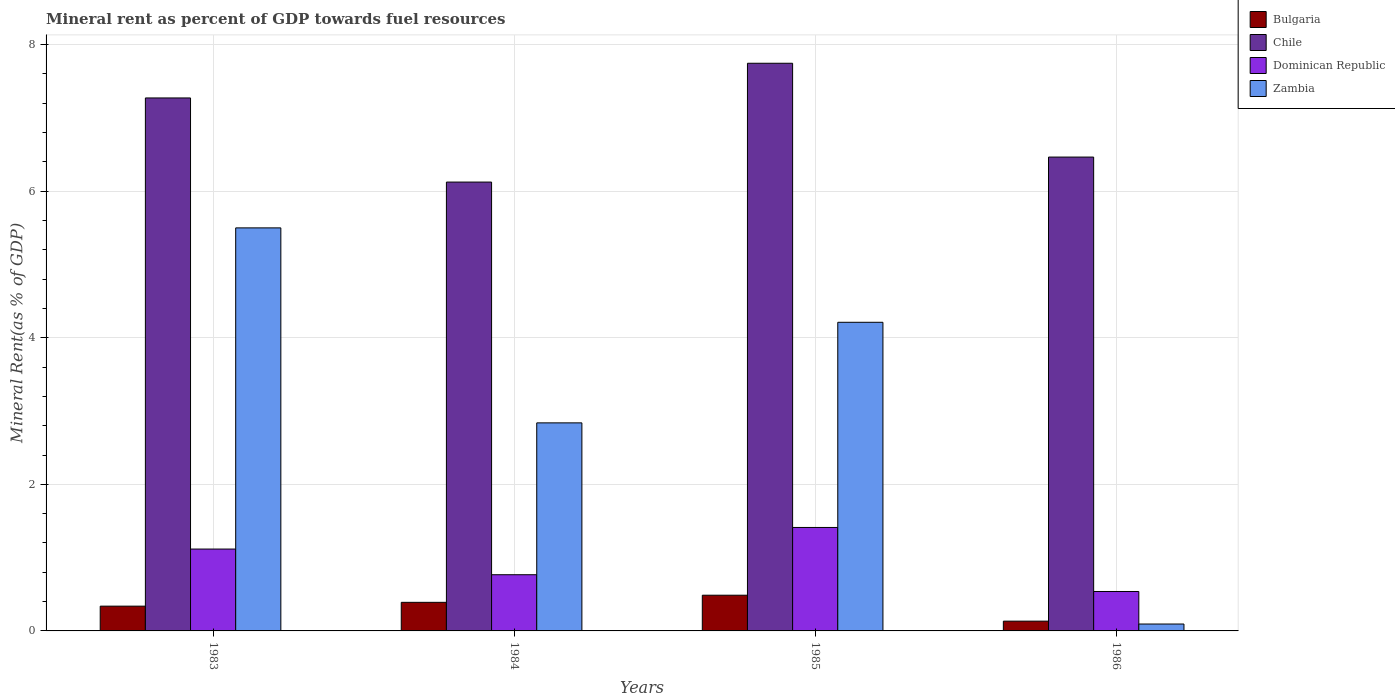Are the number of bars per tick equal to the number of legend labels?
Your answer should be compact. Yes. Are the number of bars on each tick of the X-axis equal?
Your response must be concise. Yes. How many bars are there on the 4th tick from the left?
Offer a very short reply. 4. How many bars are there on the 4th tick from the right?
Offer a terse response. 4. What is the mineral rent in Chile in 1986?
Your answer should be very brief. 6.47. Across all years, what is the maximum mineral rent in Dominican Republic?
Offer a terse response. 1.41. Across all years, what is the minimum mineral rent in Zambia?
Offer a terse response. 0.09. In which year was the mineral rent in Dominican Republic minimum?
Make the answer very short. 1986. What is the total mineral rent in Dominican Republic in the graph?
Keep it short and to the point. 3.83. What is the difference between the mineral rent in Zambia in 1983 and that in 1985?
Give a very brief answer. 1.29. What is the difference between the mineral rent in Dominican Republic in 1983 and the mineral rent in Bulgaria in 1984?
Offer a terse response. 0.73. What is the average mineral rent in Chile per year?
Give a very brief answer. 6.9. In the year 1983, what is the difference between the mineral rent in Bulgaria and mineral rent in Dominican Republic?
Ensure brevity in your answer.  -0.78. In how many years, is the mineral rent in Zambia greater than 2.4 %?
Keep it short and to the point. 3. What is the ratio of the mineral rent in Chile in 1983 to that in 1985?
Your response must be concise. 0.94. Is the difference between the mineral rent in Bulgaria in 1983 and 1984 greater than the difference between the mineral rent in Dominican Republic in 1983 and 1984?
Offer a terse response. No. What is the difference between the highest and the second highest mineral rent in Bulgaria?
Ensure brevity in your answer.  0.1. What is the difference between the highest and the lowest mineral rent in Dominican Republic?
Your answer should be very brief. 0.87. Is the sum of the mineral rent in Zambia in 1983 and 1985 greater than the maximum mineral rent in Dominican Republic across all years?
Give a very brief answer. Yes. Is it the case that in every year, the sum of the mineral rent in Chile and mineral rent in Bulgaria is greater than the sum of mineral rent in Dominican Republic and mineral rent in Zambia?
Give a very brief answer. Yes. What does the 3rd bar from the left in 1983 represents?
Provide a succinct answer. Dominican Republic. What does the 4th bar from the right in 1985 represents?
Give a very brief answer. Bulgaria. Is it the case that in every year, the sum of the mineral rent in Dominican Republic and mineral rent in Zambia is greater than the mineral rent in Bulgaria?
Your response must be concise. Yes. Are all the bars in the graph horizontal?
Provide a succinct answer. No. How many years are there in the graph?
Your response must be concise. 4. What is the difference between two consecutive major ticks on the Y-axis?
Keep it short and to the point. 2. Are the values on the major ticks of Y-axis written in scientific E-notation?
Your answer should be compact. No. Does the graph contain any zero values?
Give a very brief answer. No. Does the graph contain grids?
Offer a very short reply. Yes. How many legend labels are there?
Provide a succinct answer. 4. What is the title of the graph?
Offer a terse response. Mineral rent as percent of GDP towards fuel resources. Does "Ethiopia" appear as one of the legend labels in the graph?
Make the answer very short. No. What is the label or title of the X-axis?
Offer a terse response. Years. What is the label or title of the Y-axis?
Keep it short and to the point. Mineral Rent(as % of GDP). What is the Mineral Rent(as % of GDP) in Bulgaria in 1983?
Keep it short and to the point. 0.34. What is the Mineral Rent(as % of GDP) in Chile in 1983?
Your response must be concise. 7.27. What is the Mineral Rent(as % of GDP) of Dominican Republic in 1983?
Make the answer very short. 1.12. What is the Mineral Rent(as % of GDP) in Zambia in 1983?
Offer a terse response. 5.5. What is the Mineral Rent(as % of GDP) of Bulgaria in 1984?
Keep it short and to the point. 0.39. What is the Mineral Rent(as % of GDP) of Chile in 1984?
Provide a short and direct response. 6.12. What is the Mineral Rent(as % of GDP) in Dominican Republic in 1984?
Offer a terse response. 0.77. What is the Mineral Rent(as % of GDP) in Zambia in 1984?
Keep it short and to the point. 2.84. What is the Mineral Rent(as % of GDP) in Bulgaria in 1985?
Make the answer very short. 0.49. What is the Mineral Rent(as % of GDP) in Chile in 1985?
Provide a succinct answer. 7.75. What is the Mineral Rent(as % of GDP) of Dominican Republic in 1985?
Your response must be concise. 1.41. What is the Mineral Rent(as % of GDP) of Zambia in 1985?
Offer a very short reply. 4.21. What is the Mineral Rent(as % of GDP) of Bulgaria in 1986?
Keep it short and to the point. 0.13. What is the Mineral Rent(as % of GDP) in Chile in 1986?
Give a very brief answer. 6.47. What is the Mineral Rent(as % of GDP) of Dominican Republic in 1986?
Your answer should be very brief. 0.54. What is the Mineral Rent(as % of GDP) in Zambia in 1986?
Offer a very short reply. 0.09. Across all years, what is the maximum Mineral Rent(as % of GDP) of Bulgaria?
Your answer should be compact. 0.49. Across all years, what is the maximum Mineral Rent(as % of GDP) of Chile?
Ensure brevity in your answer.  7.75. Across all years, what is the maximum Mineral Rent(as % of GDP) of Dominican Republic?
Your answer should be compact. 1.41. Across all years, what is the maximum Mineral Rent(as % of GDP) of Zambia?
Provide a short and direct response. 5.5. Across all years, what is the minimum Mineral Rent(as % of GDP) of Bulgaria?
Your response must be concise. 0.13. Across all years, what is the minimum Mineral Rent(as % of GDP) of Chile?
Offer a terse response. 6.12. Across all years, what is the minimum Mineral Rent(as % of GDP) of Dominican Republic?
Offer a terse response. 0.54. Across all years, what is the minimum Mineral Rent(as % of GDP) of Zambia?
Ensure brevity in your answer.  0.09. What is the total Mineral Rent(as % of GDP) in Bulgaria in the graph?
Your answer should be very brief. 1.35. What is the total Mineral Rent(as % of GDP) in Chile in the graph?
Your response must be concise. 27.61. What is the total Mineral Rent(as % of GDP) in Dominican Republic in the graph?
Keep it short and to the point. 3.83. What is the total Mineral Rent(as % of GDP) in Zambia in the graph?
Your answer should be very brief. 12.64. What is the difference between the Mineral Rent(as % of GDP) in Bulgaria in 1983 and that in 1984?
Give a very brief answer. -0.05. What is the difference between the Mineral Rent(as % of GDP) of Chile in 1983 and that in 1984?
Offer a terse response. 1.15. What is the difference between the Mineral Rent(as % of GDP) of Dominican Republic in 1983 and that in 1984?
Make the answer very short. 0.35. What is the difference between the Mineral Rent(as % of GDP) of Zambia in 1983 and that in 1984?
Provide a short and direct response. 2.66. What is the difference between the Mineral Rent(as % of GDP) in Bulgaria in 1983 and that in 1985?
Make the answer very short. -0.15. What is the difference between the Mineral Rent(as % of GDP) of Chile in 1983 and that in 1985?
Give a very brief answer. -0.47. What is the difference between the Mineral Rent(as % of GDP) of Dominican Republic in 1983 and that in 1985?
Offer a terse response. -0.29. What is the difference between the Mineral Rent(as % of GDP) of Zambia in 1983 and that in 1985?
Keep it short and to the point. 1.29. What is the difference between the Mineral Rent(as % of GDP) of Bulgaria in 1983 and that in 1986?
Make the answer very short. 0.2. What is the difference between the Mineral Rent(as % of GDP) of Chile in 1983 and that in 1986?
Your answer should be compact. 0.81. What is the difference between the Mineral Rent(as % of GDP) of Dominican Republic in 1983 and that in 1986?
Provide a succinct answer. 0.58. What is the difference between the Mineral Rent(as % of GDP) of Zambia in 1983 and that in 1986?
Give a very brief answer. 5.41. What is the difference between the Mineral Rent(as % of GDP) in Bulgaria in 1984 and that in 1985?
Your answer should be very brief. -0.1. What is the difference between the Mineral Rent(as % of GDP) in Chile in 1984 and that in 1985?
Provide a succinct answer. -1.62. What is the difference between the Mineral Rent(as % of GDP) of Dominican Republic in 1984 and that in 1985?
Your response must be concise. -0.64. What is the difference between the Mineral Rent(as % of GDP) in Zambia in 1984 and that in 1985?
Your response must be concise. -1.37. What is the difference between the Mineral Rent(as % of GDP) in Bulgaria in 1984 and that in 1986?
Provide a short and direct response. 0.26. What is the difference between the Mineral Rent(as % of GDP) in Chile in 1984 and that in 1986?
Provide a short and direct response. -0.34. What is the difference between the Mineral Rent(as % of GDP) of Dominican Republic in 1984 and that in 1986?
Offer a terse response. 0.23. What is the difference between the Mineral Rent(as % of GDP) in Zambia in 1984 and that in 1986?
Give a very brief answer. 2.75. What is the difference between the Mineral Rent(as % of GDP) of Bulgaria in 1985 and that in 1986?
Keep it short and to the point. 0.35. What is the difference between the Mineral Rent(as % of GDP) in Chile in 1985 and that in 1986?
Your response must be concise. 1.28. What is the difference between the Mineral Rent(as % of GDP) in Dominican Republic in 1985 and that in 1986?
Offer a terse response. 0.87. What is the difference between the Mineral Rent(as % of GDP) of Zambia in 1985 and that in 1986?
Keep it short and to the point. 4.12. What is the difference between the Mineral Rent(as % of GDP) in Bulgaria in 1983 and the Mineral Rent(as % of GDP) in Chile in 1984?
Keep it short and to the point. -5.79. What is the difference between the Mineral Rent(as % of GDP) of Bulgaria in 1983 and the Mineral Rent(as % of GDP) of Dominican Republic in 1984?
Make the answer very short. -0.43. What is the difference between the Mineral Rent(as % of GDP) in Bulgaria in 1983 and the Mineral Rent(as % of GDP) in Zambia in 1984?
Ensure brevity in your answer.  -2.5. What is the difference between the Mineral Rent(as % of GDP) of Chile in 1983 and the Mineral Rent(as % of GDP) of Dominican Republic in 1984?
Offer a very short reply. 6.51. What is the difference between the Mineral Rent(as % of GDP) in Chile in 1983 and the Mineral Rent(as % of GDP) in Zambia in 1984?
Give a very brief answer. 4.43. What is the difference between the Mineral Rent(as % of GDP) in Dominican Republic in 1983 and the Mineral Rent(as % of GDP) in Zambia in 1984?
Provide a succinct answer. -1.72. What is the difference between the Mineral Rent(as % of GDP) of Bulgaria in 1983 and the Mineral Rent(as % of GDP) of Chile in 1985?
Offer a terse response. -7.41. What is the difference between the Mineral Rent(as % of GDP) in Bulgaria in 1983 and the Mineral Rent(as % of GDP) in Dominican Republic in 1985?
Your response must be concise. -1.07. What is the difference between the Mineral Rent(as % of GDP) in Bulgaria in 1983 and the Mineral Rent(as % of GDP) in Zambia in 1985?
Give a very brief answer. -3.87. What is the difference between the Mineral Rent(as % of GDP) in Chile in 1983 and the Mineral Rent(as % of GDP) in Dominican Republic in 1985?
Ensure brevity in your answer.  5.86. What is the difference between the Mineral Rent(as % of GDP) of Chile in 1983 and the Mineral Rent(as % of GDP) of Zambia in 1985?
Offer a terse response. 3.06. What is the difference between the Mineral Rent(as % of GDP) of Dominican Republic in 1983 and the Mineral Rent(as % of GDP) of Zambia in 1985?
Your answer should be very brief. -3.09. What is the difference between the Mineral Rent(as % of GDP) in Bulgaria in 1983 and the Mineral Rent(as % of GDP) in Chile in 1986?
Your response must be concise. -6.13. What is the difference between the Mineral Rent(as % of GDP) in Bulgaria in 1983 and the Mineral Rent(as % of GDP) in Dominican Republic in 1986?
Provide a succinct answer. -0.2. What is the difference between the Mineral Rent(as % of GDP) in Bulgaria in 1983 and the Mineral Rent(as % of GDP) in Zambia in 1986?
Keep it short and to the point. 0.24. What is the difference between the Mineral Rent(as % of GDP) of Chile in 1983 and the Mineral Rent(as % of GDP) of Dominican Republic in 1986?
Offer a terse response. 6.73. What is the difference between the Mineral Rent(as % of GDP) of Chile in 1983 and the Mineral Rent(as % of GDP) of Zambia in 1986?
Offer a very short reply. 7.18. What is the difference between the Mineral Rent(as % of GDP) of Dominican Republic in 1983 and the Mineral Rent(as % of GDP) of Zambia in 1986?
Offer a very short reply. 1.02. What is the difference between the Mineral Rent(as % of GDP) of Bulgaria in 1984 and the Mineral Rent(as % of GDP) of Chile in 1985?
Make the answer very short. -7.36. What is the difference between the Mineral Rent(as % of GDP) in Bulgaria in 1984 and the Mineral Rent(as % of GDP) in Dominican Republic in 1985?
Offer a terse response. -1.02. What is the difference between the Mineral Rent(as % of GDP) in Bulgaria in 1984 and the Mineral Rent(as % of GDP) in Zambia in 1985?
Your response must be concise. -3.82. What is the difference between the Mineral Rent(as % of GDP) in Chile in 1984 and the Mineral Rent(as % of GDP) in Dominican Republic in 1985?
Offer a terse response. 4.71. What is the difference between the Mineral Rent(as % of GDP) in Chile in 1984 and the Mineral Rent(as % of GDP) in Zambia in 1985?
Keep it short and to the point. 1.91. What is the difference between the Mineral Rent(as % of GDP) of Dominican Republic in 1984 and the Mineral Rent(as % of GDP) of Zambia in 1985?
Your answer should be very brief. -3.44. What is the difference between the Mineral Rent(as % of GDP) of Bulgaria in 1984 and the Mineral Rent(as % of GDP) of Chile in 1986?
Offer a very short reply. -6.08. What is the difference between the Mineral Rent(as % of GDP) of Bulgaria in 1984 and the Mineral Rent(as % of GDP) of Dominican Republic in 1986?
Offer a terse response. -0.15. What is the difference between the Mineral Rent(as % of GDP) of Bulgaria in 1984 and the Mineral Rent(as % of GDP) of Zambia in 1986?
Your answer should be compact. 0.3. What is the difference between the Mineral Rent(as % of GDP) in Chile in 1984 and the Mineral Rent(as % of GDP) in Dominican Republic in 1986?
Make the answer very short. 5.59. What is the difference between the Mineral Rent(as % of GDP) of Chile in 1984 and the Mineral Rent(as % of GDP) of Zambia in 1986?
Your answer should be compact. 6.03. What is the difference between the Mineral Rent(as % of GDP) in Dominican Republic in 1984 and the Mineral Rent(as % of GDP) in Zambia in 1986?
Offer a very short reply. 0.67. What is the difference between the Mineral Rent(as % of GDP) of Bulgaria in 1985 and the Mineral Rent(as % of GDP) of Chile in 1986?
Make the answer very short. -5.98. What is the difference between the Mineral Rent(as % of GDP) in Bulgaria in 1985 and the Mineral Rent(as % of GDP) in Dominican Republic in 1986?
Keep it short and to the point. -0.05. What is the difference between the Mineral Rent(as % of GDP) of Bulgaria in 1985 and the Mineral Rent(as % of GDP) of Zambia in 1986?
Keep it short and to the point. 0.39. What is the difference between the Mineral Rent(as % of GDP) of Chile in 1985 and the Mineral Rent(as % of GDP) of Dominican Republic in 1986?
Your response must be concise. 7.21. What is the difference between the Mineral Rent(as % of GDP) in Chile in 1985 and the Mineral Rent(as % of GDP) in Zambia in 1986?
Offer a terse response. 7.65. What is the difference between the Mineral Rent(as % of GDP) of Dominican Republic in 1985 and the Mineral Rent(as % of GDP) of Zambia in 1986?
Provide a short and direct response. 1.32. What is the average Mineral Rent(as % of GDP) in Bulgaria per year?
Keep it short and to the point. 0.34. What is the average Mineral Rent(as % of GDP) of Chile per year?
Your answer should be compact. 6.9. What is the average Mineral Rent(as % of GDP) in Dominican Republic per year?
Offer a very short reply. 0.96. What is the average Mineral Rent(as % of GDP) in Zambia per year?
Provide a succinct answer. 3.16. In the year 1983, what is the difference between the Mineral Rent(as % of GDP) of Bulgaria and Mineral Rent(as % of GDP) of Chile?
Your answer should be compact. -6.93. In the year 1983, what is the difference between the Mineral Rent(as % of GDP) in Bulgaria and Mineral Rent(as % of GDP) in Dominican Republic?
Give a very brief answer. -0.78. In the year 1983, what is the difference between the Mineral Rent(as % of GDP) in Bulgaria and Mineral Rent(as % of GDP) in Zambia?
Provide a succinct answer. -5.16. In the year 1983, what is the difference between the Mineral Rent(as % of GDP) of Chile and Mineral Rent(as % of GDP) of Dominican Republic?
Give a very brief answer. 6.16. In the year 1983, what is the difference between the Mineral Rent(as % of GDP) in Chile and Mineral Rent(as % of GDP) in Zambia?
Your answer should be very brief. 1.77. In the year 1983, what is the difference between the Mineral Rent(as % of GDP) in Dominican Republic and Mineral Rent(as % of GDP) in Zambia?
Keep it short and to the point. -4.38. In the year 1984, what is the difference between the Mineral Rent(as % of GDP) in Bulgaria and Mineral Rent(as % of GDP) in Chile?
Offer a very short reply. -5.73. In the year 1984, what is the difference between the Mineral Rent(as % of GDP) of Bulgaria and Mineral Rent(as % of GDP) of Dominican Republic?
Offer a very short reply. -0.38. In the year 1984, what is the difference between the Mineral Rent(as % of GDP) of Bulgaria and Mineral Rent(as % of GDP) of Zambia?
Make the answer very short. -2.45. In the year 1984, what is the difference between the Mineral Rent(as % of GDP) of Chile and Mineral Rent(as % of GDP) of Dominican Republic?
Give a very brief answer. 5.36. In the year 1984, what is the difference between the Mineral Rent(as % of GDP) in Chile and Mineral Rent(as % of GDP) in Zambia?
Give a very brief answer. 3.29. In the year 1984, what is the difference between the Mineral Rent(as % of GDP) in Dominican Republic and Mineral Rent(as % of GDP) in Zambia?
Provide a short and direct response. -2.07. In the year 1985, what is the difference between the Mineral Rent(as % of GDP) in Bulgaria and Mineral Rent(as % of GDP) in Chile?
Provide a succinct answer. -7.26. In the year 1985, what is the difference between the Mineral Rent(as % of GDP) of Bulgaria and Mineral Rent(as % of GDP) of Dominican Republic?
Make the answer very short. -0.92. In the year 1985, what is the difference between the Mineral Rent(as % of GDP) of Bulgaria and Mineral Rent(as % of GDP) of Zambia?
Provide a short and direct response. -3.72. In the year 1985, what is the difference between the Mineral Rent(as % of GDP) in Chile and Mineral Rent(as % of GDP) in Dominican Republic?
Give a very brief answer. 6.33. In the year 1985, what is the difference between the Mineral Rent(as % of GDP) in Chile and Mineral Rent(as % of GDP) in Zambia?
Provide a succinct answer. 3.53. In the year 1985, what is the difference between the Mineral Rent(as % of GDP) in Dominican Republic and Mineral Rent(as % of GDP) in Zambia?
Your response must be concise. -2.8. In the year 1986, what is the difference between the Mineral Rent(as % of GDP) of Bulgaria and Mineral Rent(as % of GDP) of Chile?
Your response must be concise. -6.33. In the year 1986, what is the difference between the Mineral Rent(as % of GDP) of Bulgaria and Mineral Rent(as % of GDP) of Dominican Republic?
Offer a terse response. -0.4. In the year 1986, what is the difference between the Mineral Rent(as % of GDP) of Bulgaria and Mineral Rent(as % of GDP) of Zambia?
Make the answer very short. 0.04. In the year 1986, what is the difference between the Mineral Rent(as % of GDP) in Chile and Mineral Rent(as % of GDP) in Dominican Republic?
Provide a succinct answer. 5.93. In the year 1986, what is the difference between the Mineral Rent(as % of GDP) in Chile and Mineral Rent(as % of GDP) in Zambia?
Your answer should be compact. 6.37. In the year 1986, what is the difference between the Mineral Rent(as % of GDP) in Dominican Republic and Mineral Rent(as % of GDP) in Zambia?
Your response must be concise. 0.44. What is the ratio of the Mineral Rent(as % of GDP) in Bulgaria in 1983 to that in 1984?
Make the answer very short. 0.87. What is the ratio of the Mineral Rent(as % of GDP) of Chile in 1983 to that in 1984?
Give a very brief answer. 1.19. What is the ratio of the Mineral Rent(as % of GDP) of Dominican Republic in 1983 to that in 1984?
Your answer should be very brief. 1.46. What is the ratio of the Mineral Rent(as % of GDP) of Zambia in 1983 to that in 1984?
Offer a very short reply. 1.94. What is the ratio of the Mineral Rent(as % of GDP) in Bulgaria in 1983 to that in 1985?
Offer a terse response. 0.69. What is the ratio of the Mineral Rent(as % of GDP) in Chile in 1983 to that in 1985?
Make the answer very short. 0.94. What is the ratio of the Mineral Rent(as % of GDP) of Dominican Republic in 1983 to that in 1985?
Ensure brevity in your answer.  0.79. What is the ratio of the Mineral Rent(as % of GDP) of Zambia in 1983 to that in 1985?
Give a very brief answer. 1.31. What is the ratio of the Mineral Rent(as % of GDP) of Bulgaria in 1983 to that in 1986?
Give a very brief answer. 2.53. What is the ratio of the Mineral Rent(as % of GDP) in Chile in 1983 to that in 1986?
Ensure brevity in your answer.  1.12. What is the ratio of the Mineral Rent(as % of GDP) of Dominican Republic in 1983 to that in 1986?
Your answer should be compact. 2.08. What is the ratio of the Mineral Rent(as % of GDP) in Zambia in 1983 to that in 1986?
Your response must be concise. 58.49. What is the ratio of the Mineral Rent(as % of GDP) of Bulgaria in 1984 to that in 1985?
Your response must be concise. 0.8. What is the ratio of the Mineral Rent(as % of GDP) in Chile in 1984 to that in 1985?
Your response must be concise. 0.79. What is the ratio of the Mineral Rent(as % of GDP) in Dominican Republic in 1984 to that in 1985?
Ensure brevity in your answer.  0.54. What is the ratio of the Mineral Rent(as % of GDP) in Zambia in 1984 to that in 1985?
Your answer should be compact. 0.67. What is the ratio of the Mineral Rent(as % of GDP) in Bulgaria in 1984 to that in 1986?
Your answer should be very brief. 2.92. What is the ratio of the Mineral Rent(as % of GDP) of Chile in 1984 to that in 1986?
Offer a terse response. 0.95. What is the ratio of the Mineral Rent(as % of GDP) of Dominican Republic in 1984 to that in 1986?
Make the answer very short. 1.43. What is the ratio of the Mineral Rent(as % of GDP) in Zambia in 1984 to that in 1986?
Make the answer very short. 30.19. What is the ratio of the Mineral Rent(as % of GDP) in Bulgaria in 1985 to that in 1986?
Ensure brevity in your answer.  3.65. What is the ratio of the Mineral Rent(as % of GDP) in Chile in 1985 to that in 1986?
Keep it short and to the point. 1.2. What is the ratio of the Mineral Rent(as % of GDP) in Dominican Republic in 1985 to that in 1986?
Give a very brief answer. 2.62. What is the ratio of the Mineral Rent(as % of GDP) of Zambia in 1985 to that in 1986?
Provide a succinct answer. 44.78. What is the difference between the highest and the second highest Mineral Rent(as % of GDP) of Bulgaria?
Your response must be concise. 0.1. What is the difference between the highest and the second highest Mineral Rent(as % of GDP) of Chile?
Offer a very short reply. 0.47. What is the difference between the highest and the second highest Mineral Rent(as % of GDP) of Dominican Republic?
Your answer should be very brief. 0.29. What is the difference between the highest and the second highest Mineral Rent(as % of GDP) in Zambia?
Keep it short and to the point. 1.29. What is the difference between the highest and the lowest Mineral Rent(as % of GDP) of Bulgaria?
Your answer should be compact. 0.35. What is the difference between the highest and the lowest Mineral Rent(as % of GDP) in Chile?
Make the answer very short. 1.62. What is the difference between the highest and the lowest Mineral Rent(as % of GDP) in Dominican Republic?
Your answer should be very brief. 0.87. What is the difference between the highest and the lowest Mineral Rent(as % of GDP) of Zambia?
Your response must be concise. 5.41. 